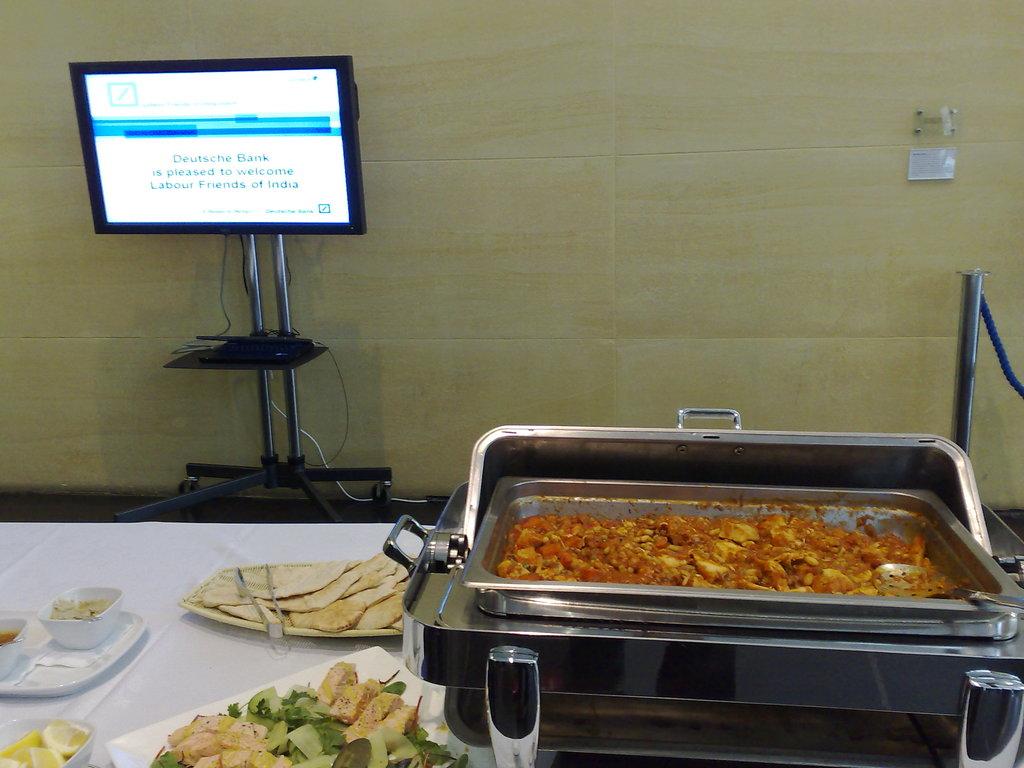What bank is hosting this event?
Offer a terse response. Deutsche bank. Labour friends of what?
Offer a terse response. India. 